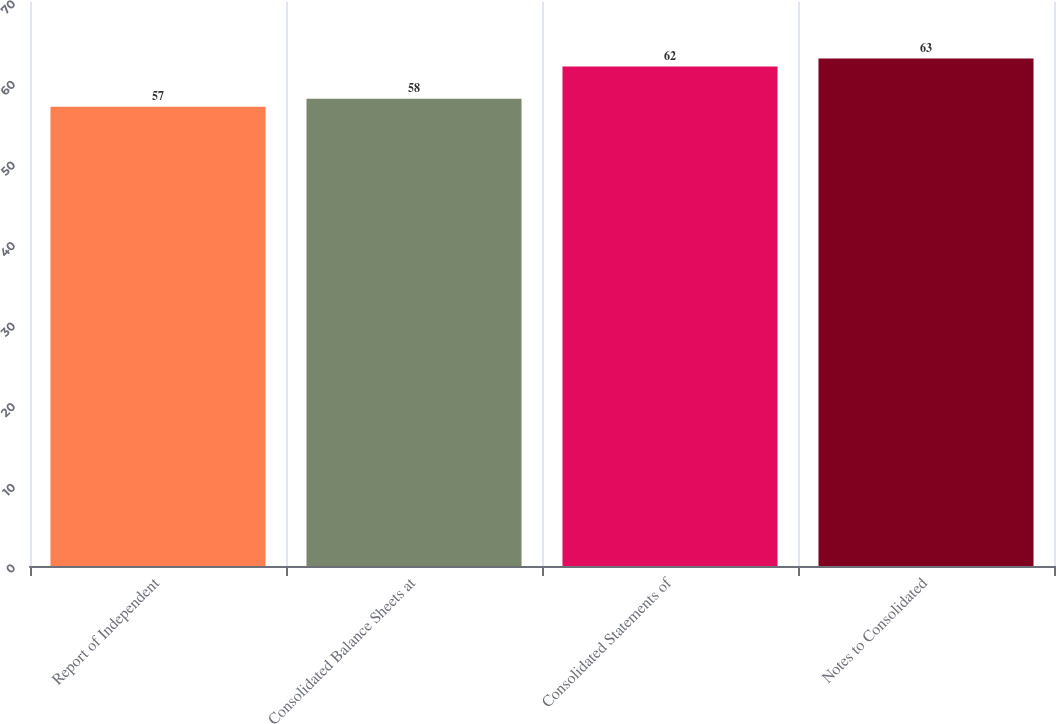<chart> <loc_0><loc_0><loc_500><loc_500><bar_chart><fcel>Report of Independent<fcel>Consolidated Balance Sheets at<fcel>Consolidated Statements of<fcel>Notes to Consolidated<nl><fcel>57<fcel>58<fcel>62<fcel>63<nl></chart> 